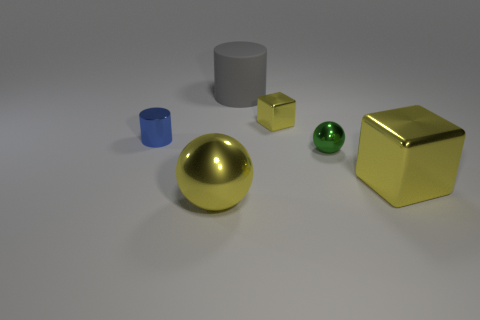Add 2 large blue matte cubes. How many objects exist? 8 Subtract all spheres. How many objects are left? 4 Subtract 0 blue cubes. How many objects are left? 6 Subtract all yellow shiny things. Subtract all spheres. How many objects are left? 1 Add 4 metal blocks. How many metal blocks are left? 6 Add 6 big cyan spheres. How many big cyan spheres exist? 6 